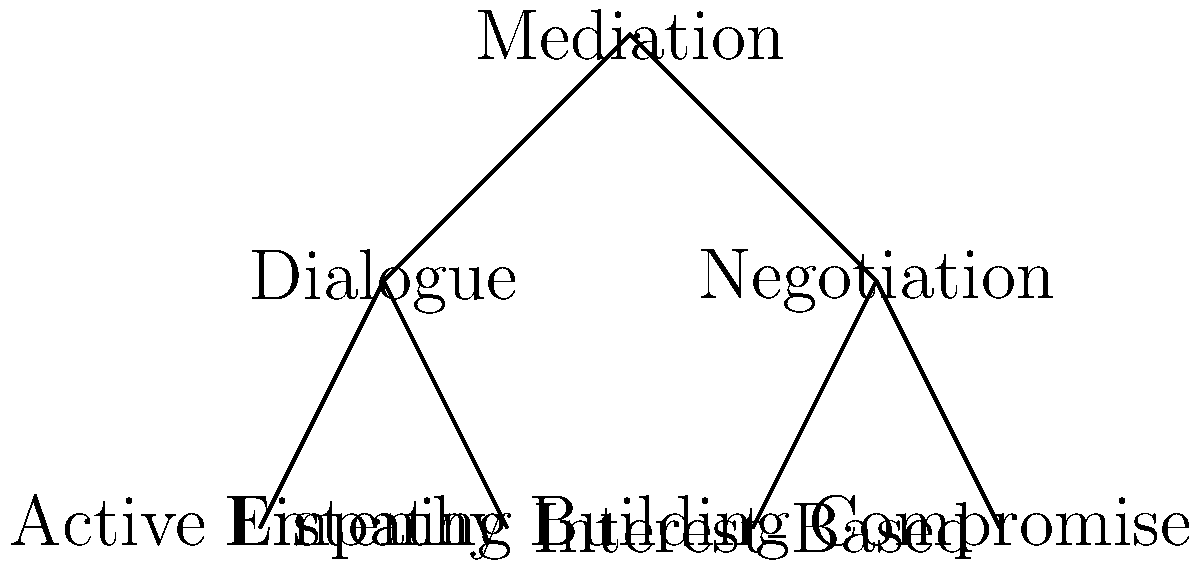In a Bollywood-inspired mediation process between two feuding film families, which conflict resolution strategy focuses on understanding the underlying needs and motivations of both parties, similar to how a director aims to bring out the best in actors? To answer this question, let's break down the conflict resolution strategies presented in the tree network:

1. The root node represents the overall "Mediation" process.

2. The first level branches into two main strategies:
   a) Dialogue
   b) Negotiation

3. Under "Dialogue," we have two sub-strategies:
   a) Active Listening
   b) Empathy Building

4. Under "Negotiation," we have two sub-strategies:
   a) Interest-Based
   b) Compromise

Now, let's consider each strategy in the context of the question:

1. Active Listening: This involves carefully hearing what each party says, but doesn't necessarily focus on understanding underlying motivations.

2. Empathy Building: This strategy aims to create mutual understanding, but doesn't directly address needs and motivations.

3. Compromise: This involves each party giving up something to reach an agreement, but doesn't focus on understanding underlying needs.

4. Interest-Based: This strategy focuses on identifying and addressing the underlying needs, interests, and motivations of both parties. It aims to find solutions that satisfy these core interests, similar to how a director works to bring out the best in actors by understanding their motivations and needs in a role.

In the context of feuding Bollywood film families, an interest-based approach would seek to understand the deeper reasons behind the conflict, such as creative differences, family legacy, or industry recognition, and find solutions that address these underlying concerns.
Answer: Interest-Based 